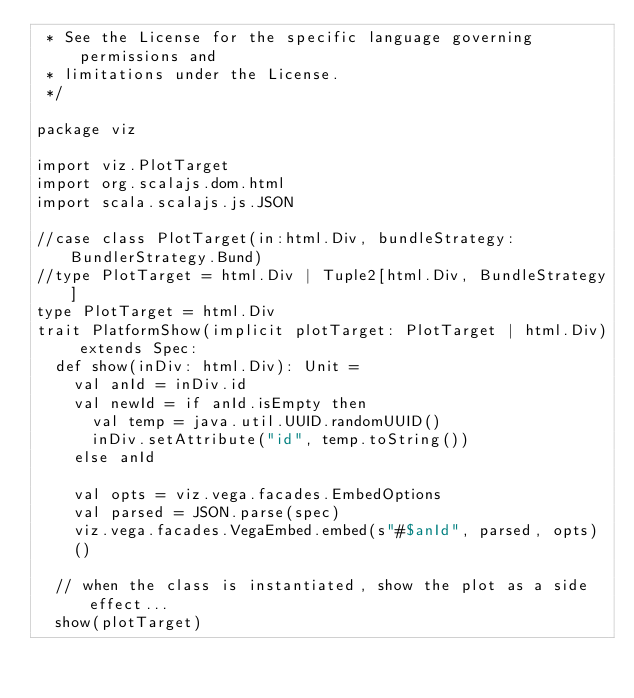<code> <loc_0><loc_0><loc_500><loc_500><_Scala_> * See the License for the specific language governing permissions and
 * limitations under the License.
 */

package viz

import viz.PlotTarget
import org.scalajs.dom.html
import scala.scalajs.js.JSON

//case class PlotTarget(in:html.Div, bundleStrategy: BundlerStrategy.Bund)
//type PlotTarget = html.Div | Tuple2[html.Div, BundleStrategy]
type PlotTarget = html.Div
trait PlatformShow(implicit plotTarget: PlotTarget | html.Div) extends Spec:
  def show(inDiv: html.Div): Unit =
    val anId = inDiv.id
    val newId = if anId.isEmpty then
      val temp = java.util.UUID.randomUUID()
      inDiv.setAttribute("id", temp.toString())
    else anId

    val opts = viz.vega.facades.EmbedOptions
    val parsed = JSON.parse(spec)
    viz.vega.facades.VegaEmbed.embed(s"#$anId", parsed, opts)
    ()

  // when the class is instantiated, show the plot as a side effect...
  show(plotTarget)
</code> 